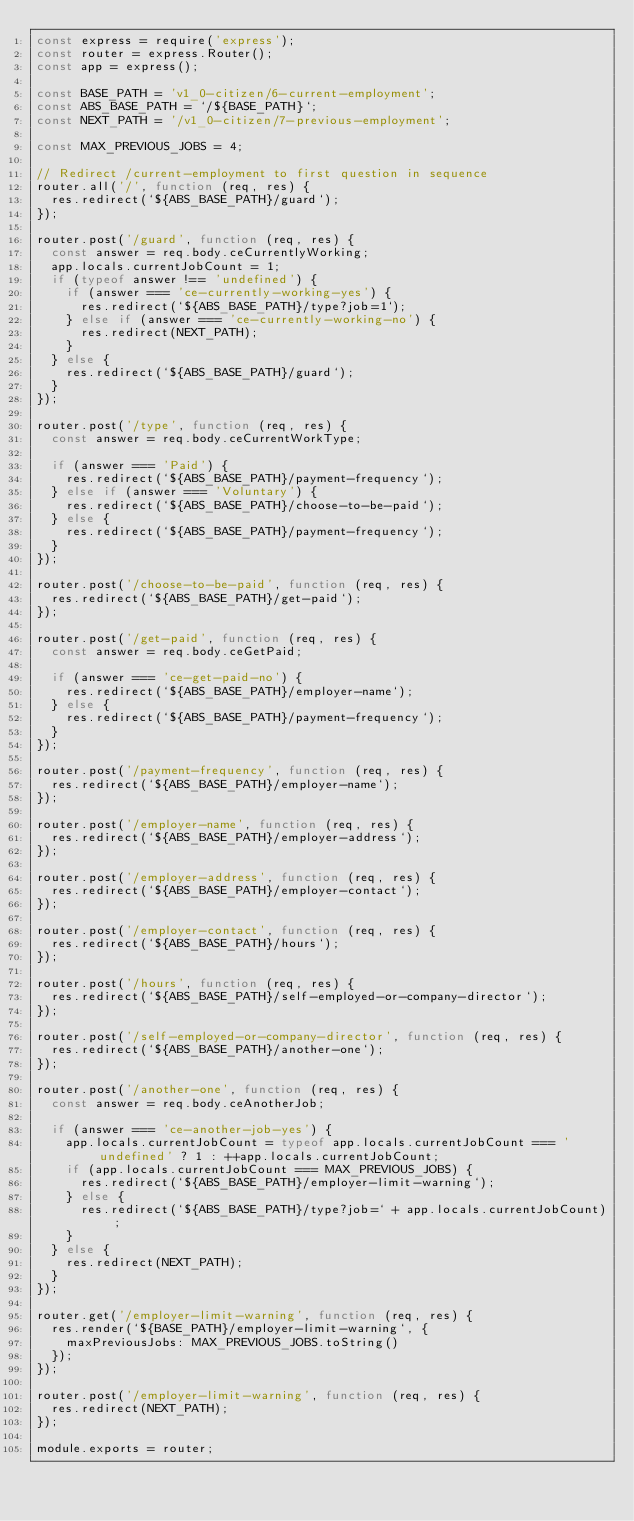Convert code to text. <code><loc_0><loc_0><loc_500><loc_500><_JavaScript_>const express = require('express');
const router = express.Router();
const app = express();

const BASE_PATH = 'v1_0-citizen/6-current-employment';
const ABS_BASE_PATH = `/${BASE_PATH}`;
const NEXT_PATH = '/v1_0-citizen/7-previous-employment';

const MAX_PREVIOUS_JOBS = 4;

// Redirect /current-employment to first question in sequence
router.all('/', function (req, res) {
  res.redirect(`${ABS_BASE_PATH}/guard`);
});

router.post('/guard', function (req, res) {
  const answer = req.body.ceCurrentlyWorking;
  app.locals.currentJobCount = 1;
  if (typeof answer !== 'undefined') {
    if (answer === 'ce-currently-working-yes') {
      res.redirect(`${ABS_BASE_PATH}/type?job=1`);
    } else if (answer === 'ce-currently-working-no') {
      res.redirect(NEXT_PATH);
    }
  } else {
    res.redirect(`${ABS_BASE_PATH}/guard`);
  }
});

router.post('/type', function (req, res) {
  const answer = req.body.ceCurrentWorkType;

  if (answer === 'Paid') {
    res.redirect(`${ABS_BASE_PATH}/payment-frequency`);
  } else if (answer === 'Voluntary') {
    res.redirect(`${ABS_BASE_PATH}/choose-to-be-paid`);
  } else {
    res.redirect(`${ABS_BASE_PATH}/payment-frequency`);
  }
});

router.post('/choose-to-be-paid', function (req, res) {
  res.redirect(`${ABS_BASE_PATH}/get-paid`);
});

router.post('/get-paid', function (req, res) {
  const answer = req.body.ceGetPaid;

  if (answer === 'ce-get-paid-no') {
    res.redirect(`${ABS_BASE_PATH}/employer-name`);
  } else {
    res.redirect(`${ABS_BASE_PATH}/payment-frequency`);
  }
});

router.post('/payment-frequency', function (req, res) {
  res.redirect(`${ABS_BASE_PATH}/employer-name`);
});

router.post('/employer-name', function (req, res) {
  res.redirect(`${ABS_BASE_PATH}/employer-address`);
});

router.post('/employer-address', function (req, res) {
  res.redirect(`${ABS_BASE_PATH}/employer-contact`);
});

router.post('/employer-contact', function (req, res) {
  res.redirect(`${ABS_BASE_PATH}/hours`);
});

router.post('/hours', function (req, res) {
  res.redirect(`${ABS_BASE_PATH}/self-employed-or-company-director`);
});

router.post('/self-employed-or-company-director', function (req, res) {
  res.redirect(`${ABS_BASE_PATH}/another-one`);
});

router.post('/another-one', function (req, res) {
  const answer = req.body.ceAnotherJob;

  if (answer === 'ce-another-job-yes') {
    app.locals.currentJobCount = typeof app.locals.currentJobCount === 'undefined' ? 1 : ++app.locals.currentJobCount;
    if (app.locals.currentJobCount === MAX_PREVIOUS_JOBS) {
      res.redirect(`${ABS_BASE_PATH}/employer-limit-warning`);
    } else {
      res.redirect(`${ABS_BASE_PATH}/type?job=` + app.locals.currentJobCount);
    }
  } else {
    res.redirect(NEXT_PATH);
  }
});

router.get('/employer-limit-warning', function (req, res) {
  res.render(`${BASE_PATH}/employer-limit-warning`, {
    maxPreviousJobs: MAX_PREVIOUS_JOBS.toString()
  });
});

router.post('/employer-limit-warning', function (req, res) {
  res.redirect(NEXT_PATH);
});

module.exports = router;
</code> 